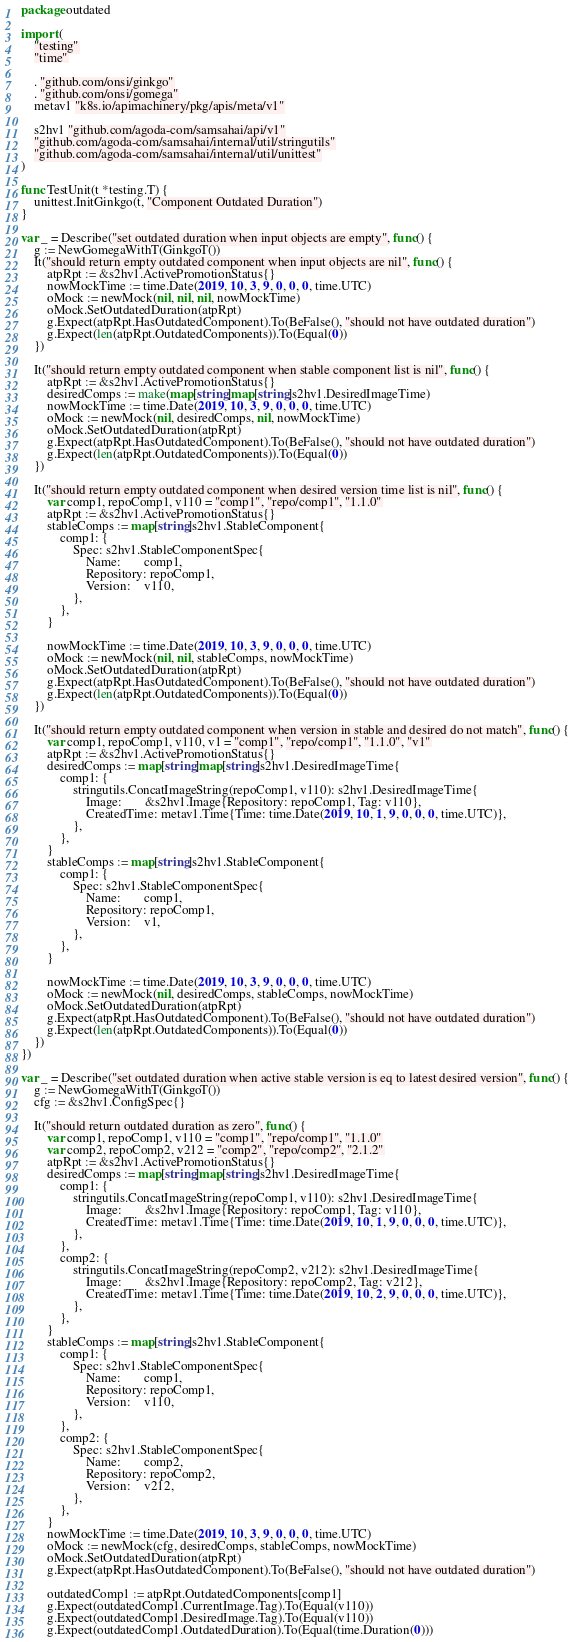<code> <loc_0><loc_0><loc_500><loc_500><_Go_>package outdated

import (
	"testing"
	"time"

	. "github.com/onsi/ginkgo"
	. "github.com/onsi/gomega"
	metav1 "k8s.io/apimachinery/pkg/apis/meta/v1"

	s2hv1 "github.com/agoda-com/samsahai/api/v1"
	"github.com/agoda-com/samsahai/internal/util/stringutils"
	"github.com/agoda-com/samsahai/internal/util/unittest"
)

func TestUnit(t *testing.T) {
	unittest.InitGinkgo(t, "Component Outdated Duration")
}

var _ = Describe("set outdated duration when input objects are empty", func() {
	g := NewGomegaWithT(GinkgoT())
	It("should return empty outdated component when input objects are nil", func() {
		atpRpt := &s2hv1.ActivePromotionStatus{}
		nowMockTime := time.Date(2019, 10, 3, 9, 0, 0, 0, time.UTC)
		oMock := newMock(nil, nil, nil, nowMockTime)
		oMock.SetOutdatedDuration(atpRpt)
		g.Expect(atpRpt.HasOutdatedComponent).To(BeFalse(), "should not have outdated duration")
		g.Expect(len(atpRpt.OutdatedComponents)).To(Equal(0))
	})

	It("should return empty outdated component when stable component list is nil", func() {
		atpRpt := &s2hv1.ActivePromotionStatus{}
		desiredComps := make(map[string]map[string]s2hv1.DesiredImageTime)
		nowMockTime := time.Date(2019, 10, 3, 9, 0, 0, 0, time.UTC)
		oMock := newMock(nil, desiredComps, nil, nowMockTime)
		oMock.SetOutdatedDuration(atpRpt)
		g.Expect(atpRpt.HasOutdatedComponent).To(BeFalse(), "should not have outdated duration")
		g.Expect(len(atpRpt.OutdatedComponents)).To(Equal(0))
	})

	It("should return empty outdated component when desired version time list is nil", func() {
		var comp1, repoComp1, v110 = "comp1", "repo/comp1", "1.1.0"
		atpRpt := &s2hv1.ActivePromotionStatus{}
		stableComps := map[string]s2hv1.StableComponent{
			comp1: {
				Spec: s2hv1.StableComponentSpec{
					Name:       comp1,
					Repository: repoComp1,
					Version:    v110,
				},
			},
		}

		nowMockTime := time.Date(2019, 10, 3, 9, 0, 0, 0, time.UTC)
		oMock := newMock(nil, nil, stableComps, nowMockTime)
		oMock.SetOutdatedDuration(atpRpt)
		g.Expect(atpRpt.HasOutdatedComponent).To(BeFalse(), "should not have outdated duration")
		g.Expect(len(atpRpt.OutdatedComponents)).To(Equal(0))
	})

	It("should return empty outdated component when version in stable and desired do not match", func() {
		var comp1, repoComp1, v110, v1 = "comp1", "repo/comp1", "1.1.0", "v1"
		atpRpt := &s2hv1.ActivePromotionStatus{}
		desiredComps := map[string]map[string]s2hv1.DesiredImageTime{
			comp1: {
				stringutils.ConcatImageString(repoComp1, v110): s2hv1.DesiredImageTime{
					Image:       &s2hv1.Image{Repository: repoComp1, Tag: v110},
					CreatedTime: metav1.Time{Time: time.Date(2019, 10, 1, 9, 0, 0, 0, time.UTC)},
				},
			},
		}
		stableComps := map[string]s2hv1.StableComponent{
			comp1: {
				Spec: s2hv1.StableComponentSpec{
					Name:       comp1,
					Repository: repoComp1,
					Version:    v1,
				},
			},
		}

		nowMockTime := time.Date(2019, 10, 3, 9, 0, 0, 0, time.UTC)
		oMock := newMock(nil, desiredComps, stableComps, nowMockTime)
		oMock.SetOutdatedDuration(atpRpt)
		g.Expect(atpRpt.HasOutdatedComponent).To(BeFalse(), "should not have outdated duration")
		g.Expect(len(atpRpt.OutdatedComponents)).To(Equal(0))
	})
})

var _ = Describe("set outdated duration when active stable version is eq to latest desired version", func() {
	g := NewGomegaWithT(GinkgoT())
	cfg := &s2hv1.ConfigSpec{}

	It("should return outdated duration as zero", func() {
		var comp1, repoComp1, v110 = "comp1", "repo/comp1", "1.1.0"
		var comp2, repoComp2, v212 = "comp2", "repo/comp2", "2.1.2"
		atpRpt := &s2hv1.ActivePromotionStatus{}
		desiredComps := map[string]map[string]s2hv1.DesiredImageTime{
			comp1: {
				stringutils.ConcatImageString(repoComp1, v110): s2hv1.DesiredImageTime{
					Image:       &s2hv1.Image{Repository: repoComp1, Tag: v110},
					CreatedTime: metav1.Time{Time: time.Date(2019, 10, 1, 9, 0, 0, 0, time.UTC)},
				},
			},
			comp2: {
				stringutils.ConcatImageString(repoComp2, v212): s2hv1.DesiredImageTime{
					Image:       &s2hv1.Image{Repository: repoComp2, Tag: v212},
					CreatedTime: metav1.Time{Time: time.Date(2019, 10, 2, 9, 0, 0, 0, time.UTC)},
				},
			},
		}
		stableComps := map[string]s2hv1.StableComponent{
			comp1: {
				Spec: s2hv1.StableComponentSpec{
					Name:       comp1,
					Repository: repoComp1,
					Version:    v110,
				},
			},
			comp2: {
				Spec: s2hv1.StableComponentSpec{
					Name:       comp2,
					Repository: repoComp2,
					Version:    v212,
				},
			},
		}
		nowMockTime := time.Date(2019, 10, 3, 9, 0, 0, 0, time.UTC)
		oMock := newMock(cfg, desiredComps, stableComps, nowMockTime)
		oMock.SetOutdatedDuration(atpRpt)
		g.Expect(atpRpt.HasOutdatedComponent).To(BeFalse(), "should not have outdated duration")

		outdatedComp1 := atpRpt.OutdatedComponents[comp1]
		g.Expect(outdatedComp1.CurrentImage.Tag).To(Equal(v110))
		g.Expect(outdatedComp1.DesiredImage.Tag).To(Equal(v110))
		g.Expect(outdatedComp1.OutdatedDuration).To(Equal(time.Duration(0)))
</code> 